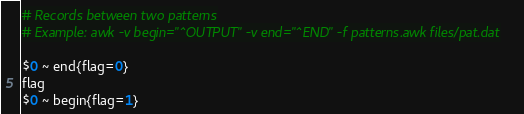<code> <loc_0><loc_0><loc_500><loc_500><_Awk_># Records between two patterns
# Example: awk -v begin="^OUTPUT" -v end="^END" -f patterns.awk files/pat.dat

$0 ~ end{flag=0}
flag
$0 ~ begin{flag=1}</code> 